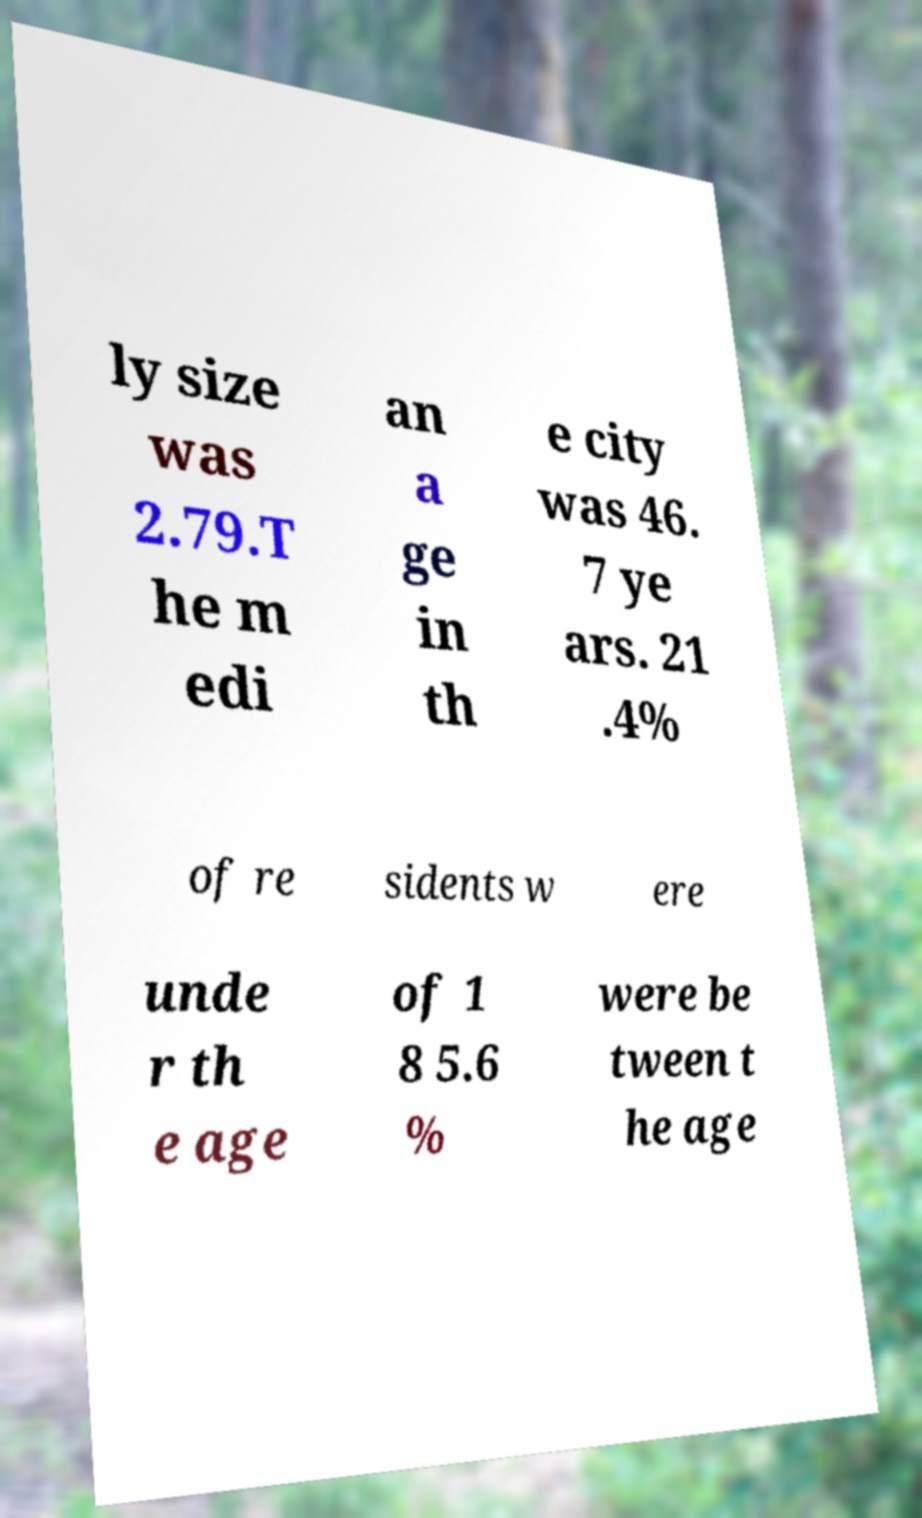Could you assist in decoding the text presented in this image and type it out clearly? ly size was 2.79.T he m edi an a ge in th e city was 46. 7 ye ars. 21 .4% of re sidents w ere unde r th e age of 1 8 5.6 % were be tween t he age 